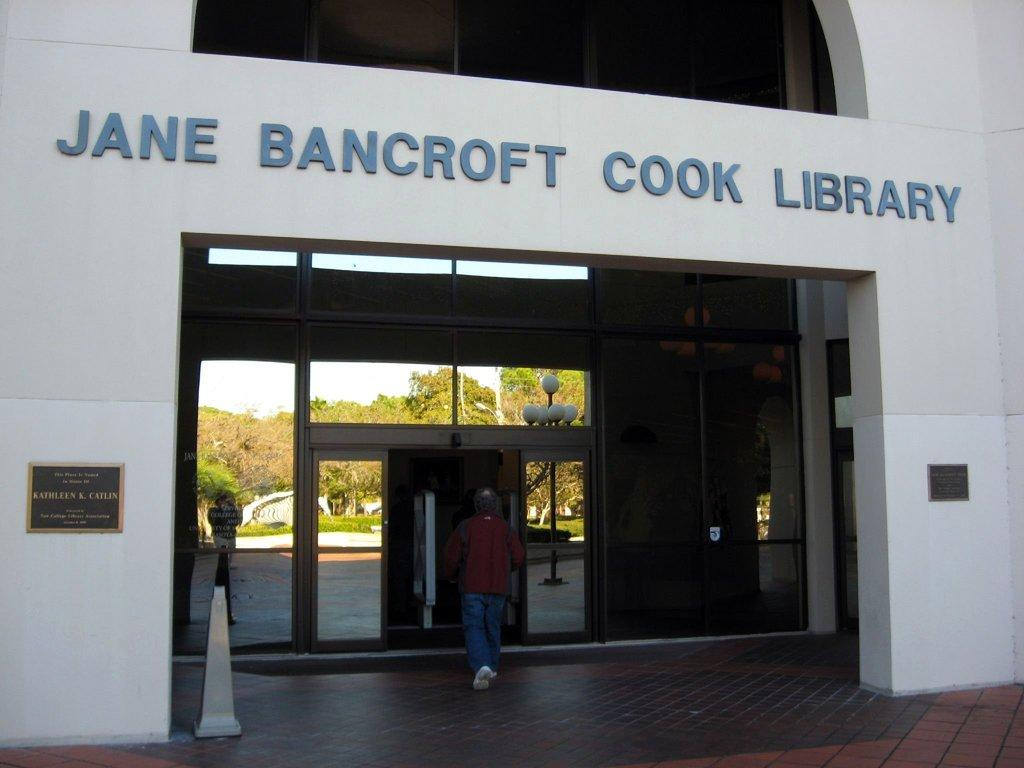What is the main subject of the image? There is a person walking in the image. Where is the person located in the image? The person is in the middle of the image. What can be seen in the background of the image? There is an entrance to a building in the background of the image. What type of copper material is being discussed by the person in the image? There is no indication in the image that the person is discussing any copper material, as the focus is on the person walking. 